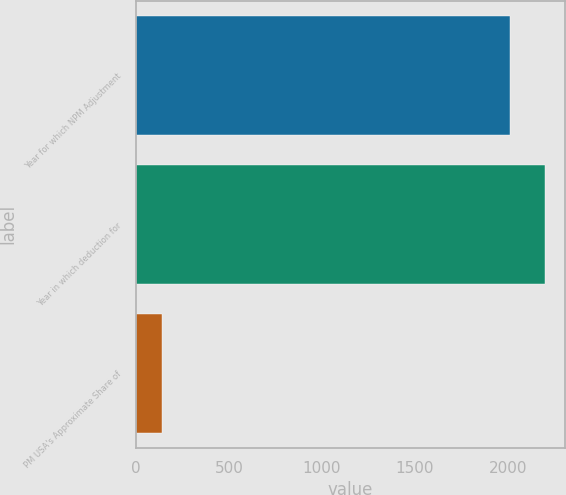<chart> <loc_0><loc_0><loc_500><loc_500><bar_chart><fcel>Year for which NPM Adjustment<fcel>Year in which deduction for<fcel>PM USA's Approximate Share of<nl><fcel>2011<fcel>2198.7<fcel>137<nl></chart> 